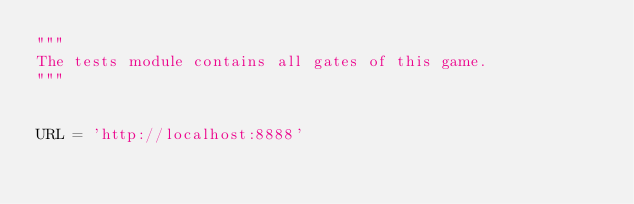<code> <loc_0><loc_0><loc_500><loc_500><_Python_>"""
The tests module contains all gates of this game.
"""


URL = 'http://localhost:8888'
</code> 